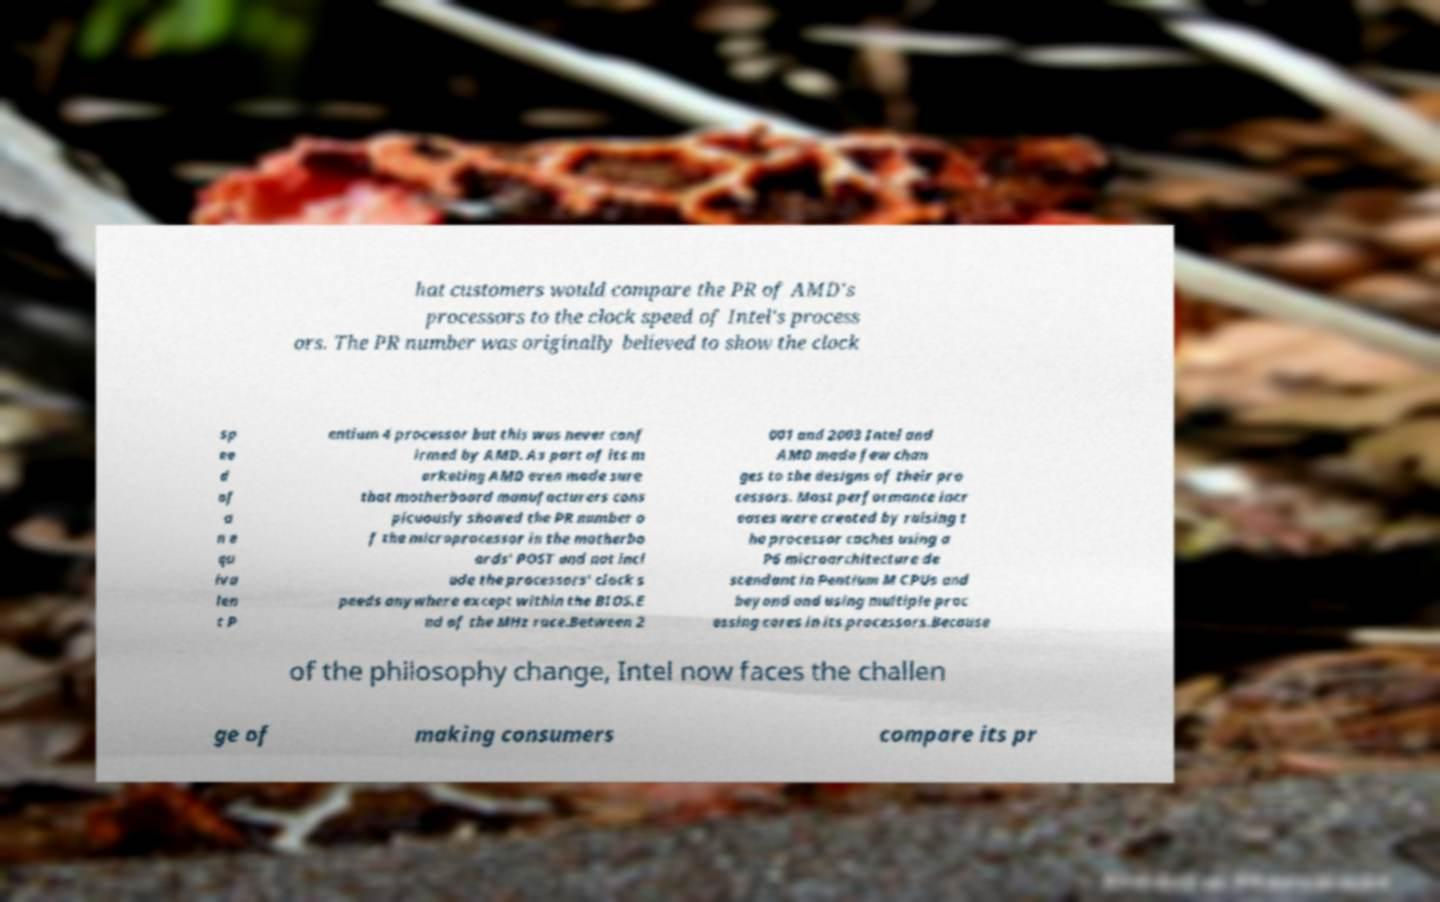Can you read and provide the text displayed in the image?This photo seems to have some interesting text. Can you extract and type it out for me? hat customers would compare the PR of AMD's processors to the clock speed of Intel's process ors. The PR number was originally believed to show the clock sp ee d of a n e qu iva len t P entium 4 processor but this was never conf irmed by AMD. As part of its m arketing AMD even made sure that motherboard manufacturers cons picuously showed the PR number o f the microprocessor in the motherbo ards' POST and not incl ude the processors' clock s peeds anywhere except within the BIOS.E nd of the MHz race.Between 2 001 and 2003 Intel and AMD made few chan ges to the designs of their pro cessors. Most performance incr eases were created by raising t he processor caches using a P6 microarchitecture de scendant in Pentium M CPUs and beyond and using multiple proc essing cores in its processors.Because of the philosophy change, Intel now faces the challen ge of making consumers compare its pr 